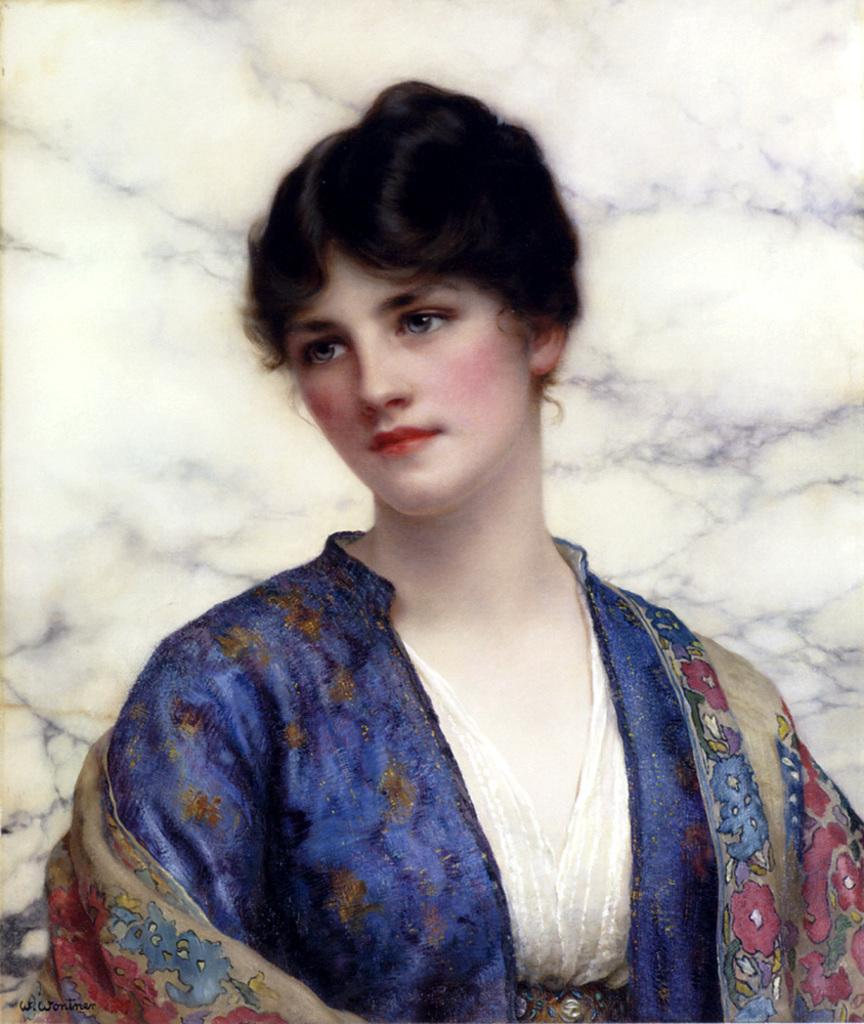What is the main subject of the painting in the image? The main subject of the painting in the image is a woman. Is there any text present in the image? Yes, there is text written in the bottom left corner of the image. What type of church can be seen in the top right corner of the image? There is no church present in the image; it only contains a painting of a woman and text in the bottom left corner. 